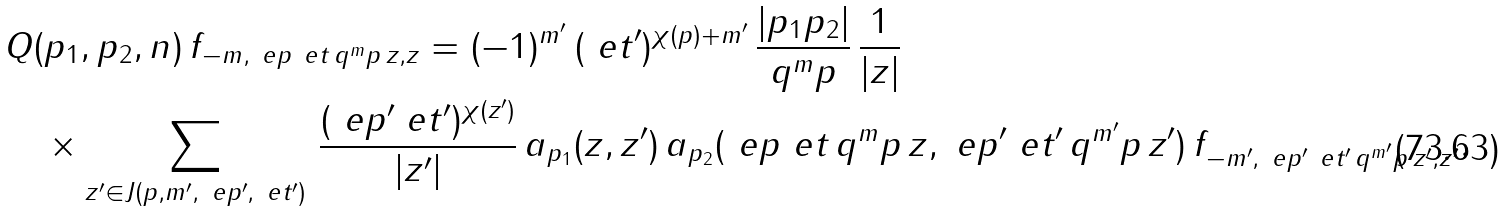Convert formula to latex. <formula><loc_0><loc_0><loc_500><loc_500>& Q ( p _ { 1 } , p _ { 2 } , n ) \, f _ { - m , \ e p \ e t \, q ^ { m } p \, z , z } = ( - 1 ) ^ { m ^ { \prime } } \, ( \ e t ^ { \prime } ) ^ { \chi ( p ) + m ^ { \prime } } \, \frac { | p _ { 1 } p _ { 2 } | } { q ^ { m } p } \, \frac { 1 } { | z | } \, \\ & \quad \times \sum _ { z ^ { \prime } \in J ( p , m ^ { \prime } , \ e p ^ { \prime } , \ e t ^ { \prime } ) } \, \frac { ( \ e p ^ { \prime } \ e t ^ { \prime } ) ^ { \chi ( z ^ { \prime } ) } } { | z ^ { \prime } | } \, a _ { p _ { 1 } } ( z , z ^ { \prime } ) \, a _ { p _ { 2 } } ( \ e p \ e t \, q ^ { m } p \, z , \ e p ^ { \prime } \ e t ^ { \prime } \, q ^ { m ^ { \prime } } p \, z ^ { \prime } ) \, f _ { - m ^ { \prime } , \ e p ^ { \prime } \ e t ^ { \prime } \, q ^ { m ^ { \prime } } p \, z ^ { \prime } , z ^ { \prime } } .</formula> 